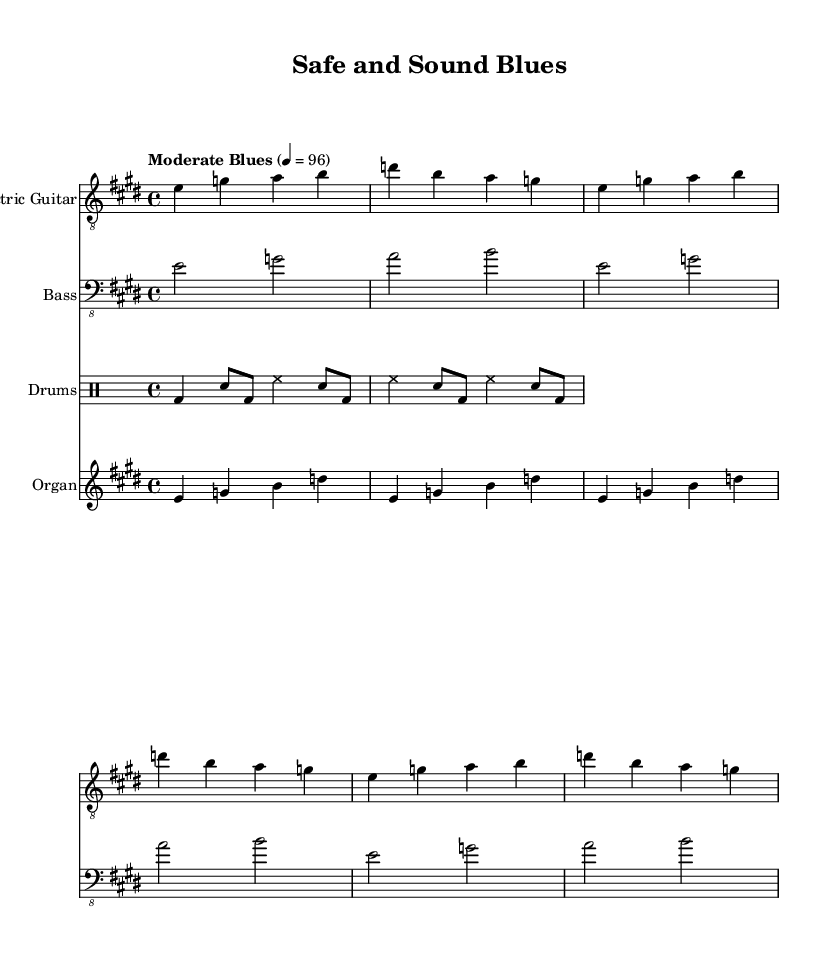What is the key signature of this music? The key signature is E major, which has four sharps (F#, C#, G#, D#).
Answer: E major What is the time signature of this music? The time signature at the beginning shows 4/4, indicating four beats in a measure.
Answer: 4/4 What is the tempo marking for this piece? The tempo marking indicates “Moderate Blues” with a metronome marking of quarter note = 96 beats per minute.
Answer: Moderate Blues How many measures are in the verse section? The verse consists of two measures as indicated by the lyrics below the musical notes.
Answer: 2 measures What instruments are featured in this composition? The composition features an electric guitar, bass, drums, and organ, as shown by the instrument names on the staves.
Answer: Electric Guitar, Bass, Drums, Organ Which instrument plays the longest notes, and what are they? The bass guitar plays longer notes, specifically half notes, while the other instruments typically play shorter notes.
Answer: Bass guitar, half notes What themes are explored in the lyrics of this electric blues? The lyrics focus on themes of security and safety, emphasizing the advanced security systems in a home.
Answer: Security and safety 